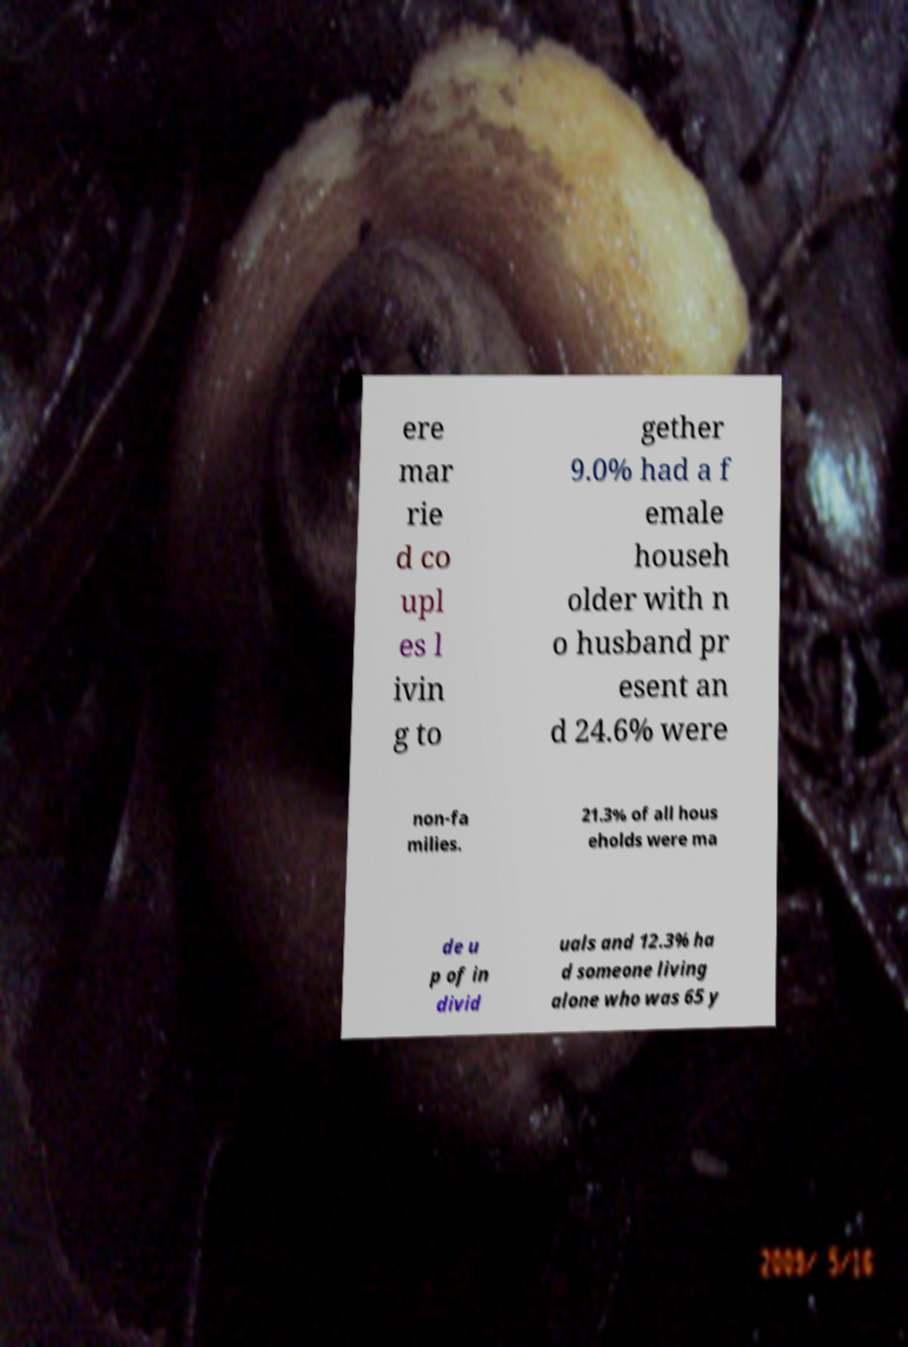Can you read and provide the text displayed in the image?This photo seems to have some interesting text. Can you extract and type it out for me? ere mar rie d co upl es l ivin g to gether 9.0% had a f emale househ older with n o husband pr esent an d 24.6% were non-fa milies. 21.3% of all hous eholds were ma de u p of in divid uals and 12.3% ha d someone living alone who was 65 y 